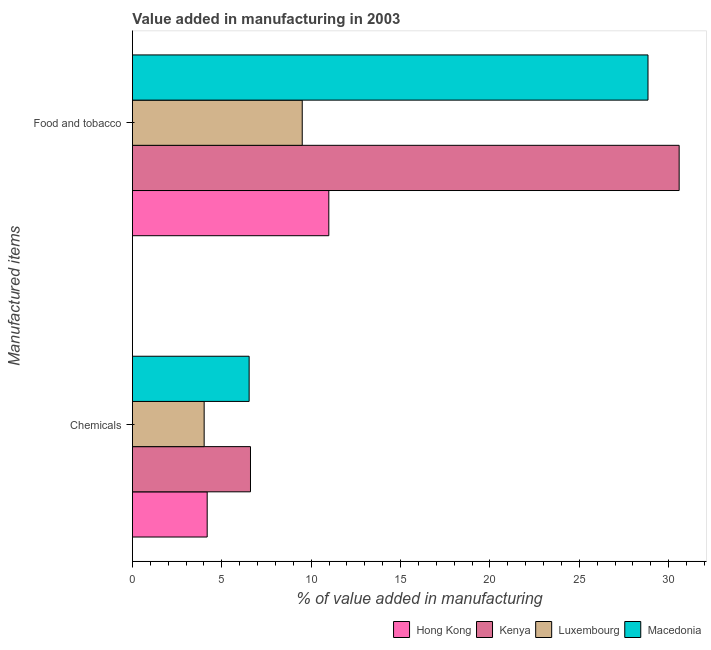How many groups of bars are there?
Ensure brevity in your answer.  2. Are the number of bars per tick equal to the number of legend labels?
Keep it short and to the point. Yes. Are the number of bars on each tick of the Y-axis equal?
Offer a terse response. Yes. How many bars are there on the 1st tick from the top?
Your response must be concise. 4. How many bars are there on the 2nd tick from the bottom?
Offer a terse response. 4. What is the label of the 2nd group of bars from the top?
Offer a terse response. Chemicals. What is the value added by manufacturing food and tobacco in Kenya?
Ensure brevity in your answer.  30.59. Across all countries, what is the maximum value added by  manufacturing chemicals?
Your answer should be compact. 6.61. Across all countries, what is the minimum value added by manufacturing food and tobacco?
Ensure brevity in your answer.  9.5. In which country was the value added by  manufacturing chemicals maximum?
Your answer should be very brief. Kenya. In which country was the value added by  manufacturing chemicals minimum?
Your answer should be compact. Luxembourg. What is the total value added by  manufacturing chemicals in the graph?
Give a very brief answer. 21.33. What is the difference between the value added by  manufacturing chemicals in Macedonia and that in Kenya?
Give a very brief answer. -0.07. What is the difference between the value added by  manufacturing chemicals in Luxembourg and the value added by manufacturing food and tobacco in Kenya?
Offer a terse response. -26.58. What is the average value added by manufacturing food and tobacco per country?
Offer a terse response. 19.98. What is the difference between the value added by manufacturing food and tobacco and value added by  manufacturing chemicals in Luxembourg?
Your answer should be very brief. 5.49. In how many countries, is the value added by manufacturing food and tobacco greater than 19 %?
Give a very brief answer. 2. What is the ratio of the value added by  manufacturing chemicals in Luxembourg to that in Hong Kong?
Provide a succinct answer. 0.96. Is the value added by  manufacturing chemicals in Kenya less than that in Macedonia?
Provide a short and direct response. No. In how many countries, is the value added by  manufacturing chemicals greater than the average value added by  manufacturing chemicals taken over all countries?
Give a very brief answer. 2. What does the 1st bar from the top in Chemicals represents?
Your answer should be compact. Macedonia. What does the 1st bar from the bottom in Food and tobacco represents?
Your answer should be compact. Hong Kong. How many countries are there in the graph?
Make the answer very short. 4. Does the graph contain any zero values?
Give a very brief answer. No. What is the title of the graph?
Give a very brief answer. Value added in manufacturing in 2003. Does "Egypt, Arab Rep." appear as one of the legend labels in the graph?
Offer a very short reply. No. What is the label or title of the X-axis?
Offer a terse response. % of value added in manufacturing. What is the label or title of the Y-axis?
Give a very brief answer. Manufactured items. What is the % of value added in manufacturing of Hong Kong in Chemicals?
Your answer should be compact. 4.18. What is the % of value added in manufacturing in Kenya in Chemicals?
Offer a terse response. 6.61. What is the % of value added in manufacturing in Luxembourg in Chemicals?
Offer a very short reply. 4.01. What is the % of value added in manufacturing of Macedonia in Chemicals?
Provide a succinct answer. 6.53. What is the % of value added in manufacturing in Hong Kong in Food and tobacco?
Offer a very short reply. 10.99. What is the % of value added in manufacturing in Kenya in Food and tobacco?
Keep it short and to the point. 30.59. What is the % of value added in manufacturing in Luxembourg in Food and tobacco?
Keep it short and to the point. 9.5. What is the % of value added in manufacturing of Macedonia in Food and tobacco?
Ensure brevity in your answer.  28.85. Across all Manufactured items, what is the maximum % of value added in manufacturing in Hong Kong?
Your answer should be very brief. 10.99. Across all Manufactured items, what is the maximum % of value added in manufacturing of Kenya?
Provide a short and direct response. 30.59. Across all Manufactured items, what is the maximum % of value added in manufacturing of Luxembourg?
Offer a very short reply. 9.5. Across all Manufactured items, what is the maximum % of value added in manufacturing of Macedonia?
Offer a terse response. 28.85. Across all Manufactured items, what is the minimum % of value added in manufacturing in Hong Kong?
Ensure brevity in your answer.  4.18. Across all Manufactured items, what is the minimum % of value added in manufacturing of Kenya?
Provide a succinct answer. 6.61. Across all Manufactured items, what is the minimum % of value added in manufacturing in Luxembourg?
Provide a succinct answer. 4.01. Across all Manufactured items, what is the minimum % of value added in manufacturing of Macedonia?
Provide a succinct answer. 6.53. What is the total % of value added in manufacturing of Hong Kong in the graph?
Make the answer very short. 15.17. What is the total % of value added in manufacturing of Kenya in the graph?
Offer a terse response. 37.19. What is the total % of value added in manufacturing in Luxembourg in the graph?
Provide a short and direct response. 13.51. What is the total % of value added in manufacturing of Macedonia in the graph?
Provide a short and direct response. 35.38. What is the difference between the % of value added in manufacturing in Hong Kong in Chemicals and that in Food and tobacco?
Give a very brief answer. -6.8. What is the difference between the % of value added in manufacturing of Kenya in Chemicals and that in Food and tobacco?
Make the answer very short. -23.98. What is the difference between the % of value added in manufacturing in Luxembourg in Chemicals and that in Food and tobacco?
Provide a succinct answer. -5.49. What is the difference between the % of value added in manufacturing of Macedonia in Chemicals and that in Food and tobacco?
Provide a short and direct response. -22.32. What is the difference between the % of value added in manufacturing of Hong Kong in Chemicals and the % of value added in manufacturing of Kenya in Food and tobacco?
Provide a short and direct response. -26.41. What is the difference between the % of value added in manufacturing in Hong Kong in Chemicals and the % of value added in manufacturing in Luxembourg in Food and tobacco?
Provide a short and direct response. -5.32. What is the difference between the % of value added in manufacturing of Hong Kong in Chemicals and the % of value added in manufacturing of Macedonia in Food and tobacco?
Keep it short and to the point. -24.66. What is the difference between the % of value added in manufacturing in Kenya in Chemicals and the % of value added in manufacturing in Luxembourg in Food and tobacco?
Your answer should be compact. -2.9. What is the difference between the % of value added in manufacturing in Kenya in Chemicals and the % of value added in manufacturing in Macedonia in Food and tobacco?
Provide a short and direct response. -22.24. What is the difference between the % of value added in manufacturing of Luxembourg in Chemicals and the % of value added in manufacturing of Macedonia in Food and tobacco?
Your answer should be very brief. -24.83. What is the average % of value added in manufacturing in Hong Kong per Manufactured items?
Ensure brevity in your answer.  7.58. What is the average % of value added in manufacturing of Kenya per Manufactured items?
Provide a succinct answer. 18.6. What is the average % of value added in manufacturing of Luxembourg per Manufactured items?
Your answer should be very brief. 6.76. What is the average % of value added in manufacturing of Macedonia per Manufactured items?
Provide a short and direct response. 17.69. What is the difference between the % of value added in manufacturing in Hong Kong and % of value added in manufacturing in Kenya in Chemicals?
Provide a succinct answer. -2.42. What is the difference between the % of value added in manufacturing in Hong Kong and % of value added in manufacturing in Luxembourg in Chemicals?
Make the answer very short. 0.17. What is the difference between the % of value added in manufacturing in Hong Kong and % of value added in manufacturing in Macedonia in Chemicals?
Your answer should be compact. -2.35. What is the difference between the % of value added in manufacturing in Kenya and % of value added in manufacturing in Luxembourg in Chemicals?
Provide a short and direct response. 2.59. What is the difference between the % of value added in manufacturing of Kenya and % of value added in manufacturing of Macedonia in Chemicals?
Offer a very short reply. 0.07. What is the difference between the % of value added in manufacturing of Luxembourg and % of value added in manufacturing of Macedonia in Chemicals?
Provide a short and direct response. -2.52. What is the difference between the % of value added in manufacturing of Hong Kong and % of value added in manufacturing of Kenya in Food and tobacco?
Offer a very short reply. -19.6. What is the difference between the % of value added in manufacturing in Hong Kong and % of value added in manufacturing in Luxembourg in Food and tobacco?
Your response must be concise. 1.49. What is the difference between the % of value added in manufacturing in Hong Kong and % of value added in manufacturing in Macedonia in Food and tobacco?
Your answer should be compact. -17.86. What is the difference between the % of value added in manufacturing of Kenya and % of value added in manufacturing of Luxembourg in Food and tobacco?
Ensure brevity in your answer.  21.09. What is the difference between the % of value added in manufacturing of Kenya and % of value added in manufacturing of Macedonia in Food and tobacco?
Offer a terse response. 1.74. What is the difference between the % of value added in manufacturing of Luxembourg and % of value added in manufacturing of Macedonia in Food and tobacco?
Make the answer very short. -19.35. What is the ratio of the % of value added in manufacturing of Hong Kong in Chemicals to that in Food and tobacco?
Offer a very short reply. 0.38. What is the ratio of the % of value added in manufacturing in Kenya in Chemicals to that in Food and tobacco?
Give a very brief answer. 0.22. What is the ratio of the % of value added in manufacturing in Luxembourg in Chemicals to that in Food and tobacco?
Offer a very short reply. 0.42. What is the ratio of the % of value added in manufacturing in Macedonia in Chemicals to that in Food and tobacco?
Your answer should be very brief. 0.23. What is the difference between the highest and the second highest % of value added in manufacturing of Hong Kong?
Make the answer very short. 6.8. What is the difference between the highest and the second highest % of value added in manufacturing in Kenya?
Keep it short and to the point. 23.98. What is the difference between the highest and the second highest % of value added in manufacturing of Luxembourg?
Give a very brief answer. 5.49. What is the difference between the highest and the second highest % of value added in manufacturing of Macedonia?
Offer a very short reply. 22.32. What is the difference between the highest and the lowest % of value added in manufacturing in Hong Kong?
Keep it short and to the point. 6.8. What is the difference between the highest and the lowest % of value added in manufacturing in Kenya?
Give a very brief answer. 23.98. What is the difference between the highest and the lowest % of value added in manufacturing of Luxembourg?
Ensure brevity in your answer.  5.49. What is the difference between the highest and the lowest % of value added in manufacturing of Macedonia?
Your answer should be very brief. 22.32. 